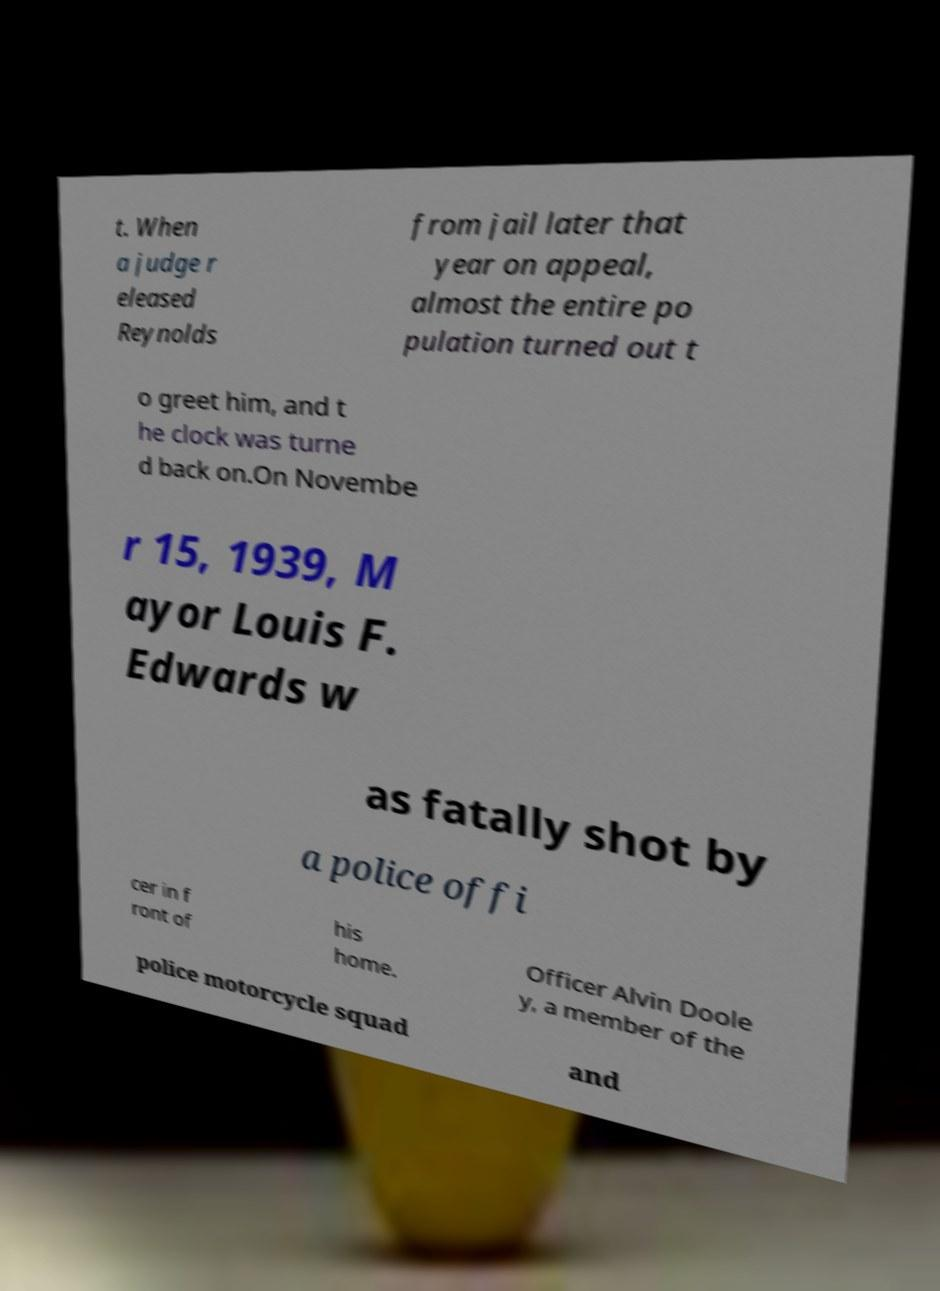What messages or text are displayed in this image? I need them in a readable, typed format. t. When a judge r eleased Reynolds from jail later that year on appeal, almost the entire po pulation turned out t o greet him, and t he clock was turne d back on.On Novembe r 15, 1939, M ayor Louis F. Edwards w as fatally shot by a police offi cer in f ront of his home. Officer Alvin Doole y, a member of the police motorcycle squad and 